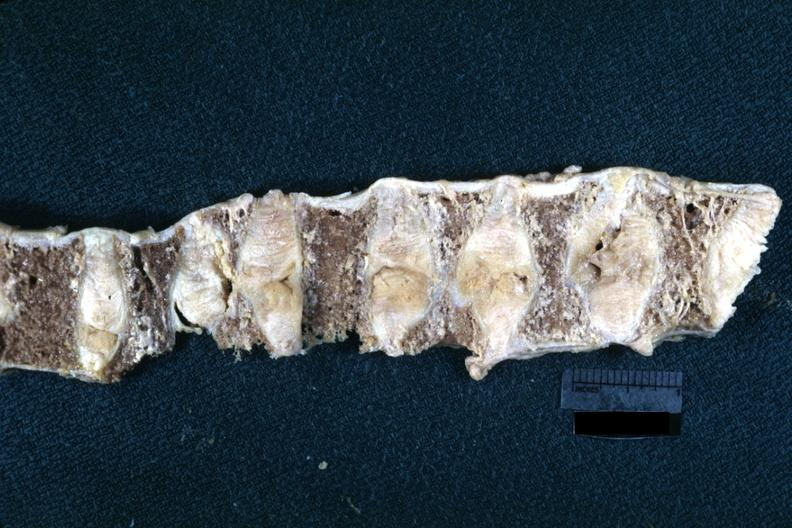what collapsed case of rheumatoid arthritis?
Answer the question using a single word or phrase. Fixed tissue lateral view vertebral bodies with many 